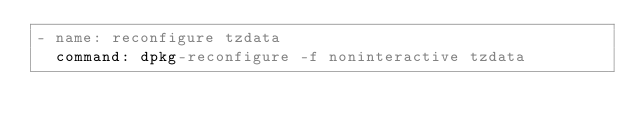<code> <loc_0><loc_0><loc_500><loc_500><_YAML_>- name: reconfigure tzdata
  command: dpkg-reconfigure -f noninteractive tzdata</code> 